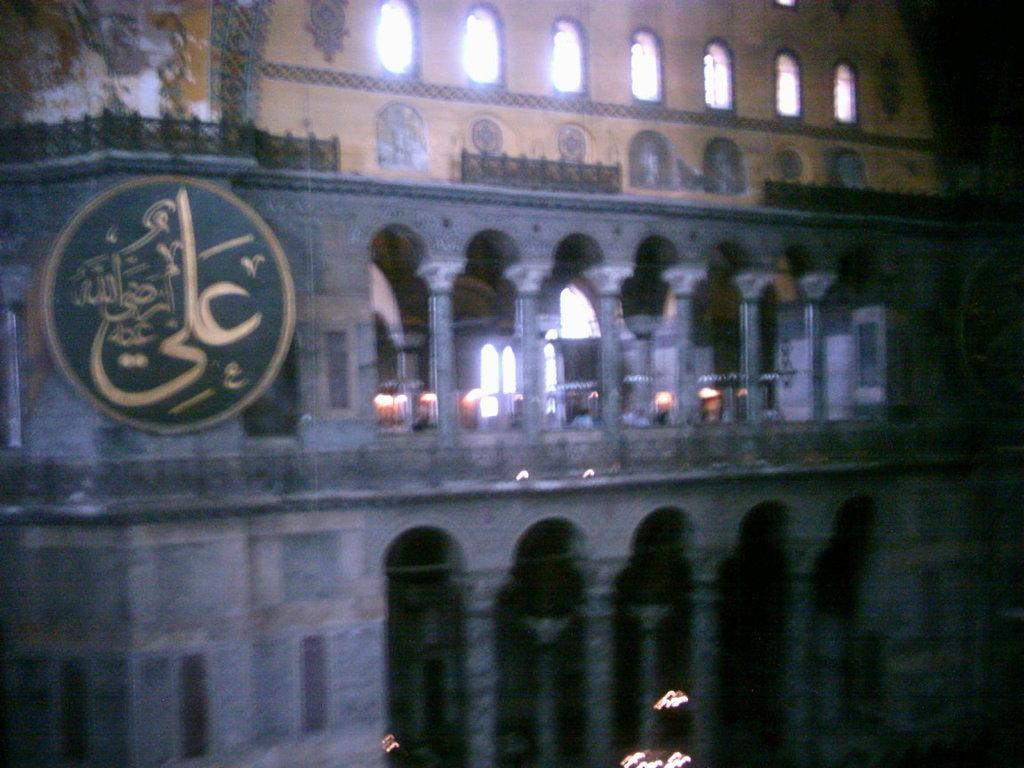What type of structure is shown in the image? The image appears to depict a fort. Can you describe any specific features or symbols in the image? There is a symbol on the left side of the image. How many dogs can be seen playing in the dirt in the image? There are no dogs or dirt present in the image; it depicts a fort with a symbol on the left side. 